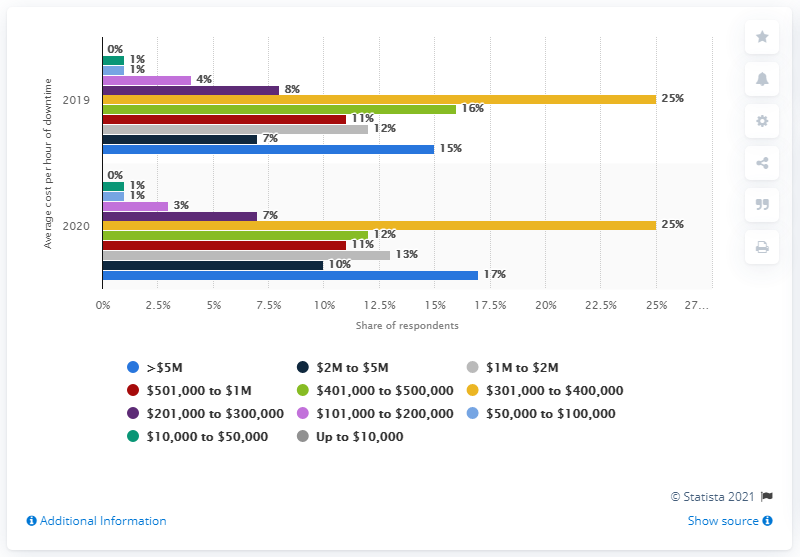Draw attention to some important aspects in this diagram. The average hourly cost of critical server outages was surveyed in 2020. 